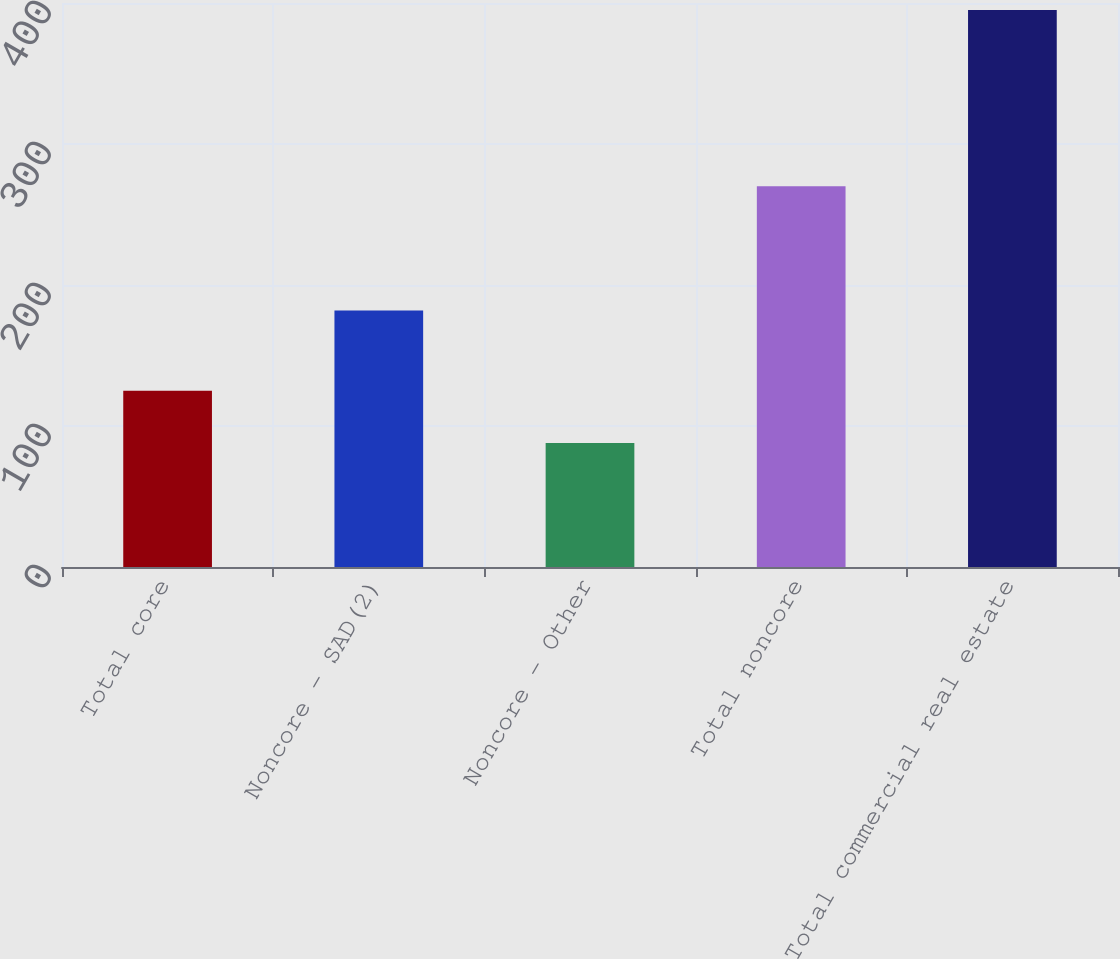<chart> <loc_0><loc_0><loc_500><loc_500><bar_chart><fcel>Total core<fcel>Noncore - SAD(2)<fcel>Noncore - Other<fcel>Total noncore<fcel>Total commercial real estate<nl><fcel>125<fcel>182<fcel>88<fcel>270<fcel>395<nl></chart> 